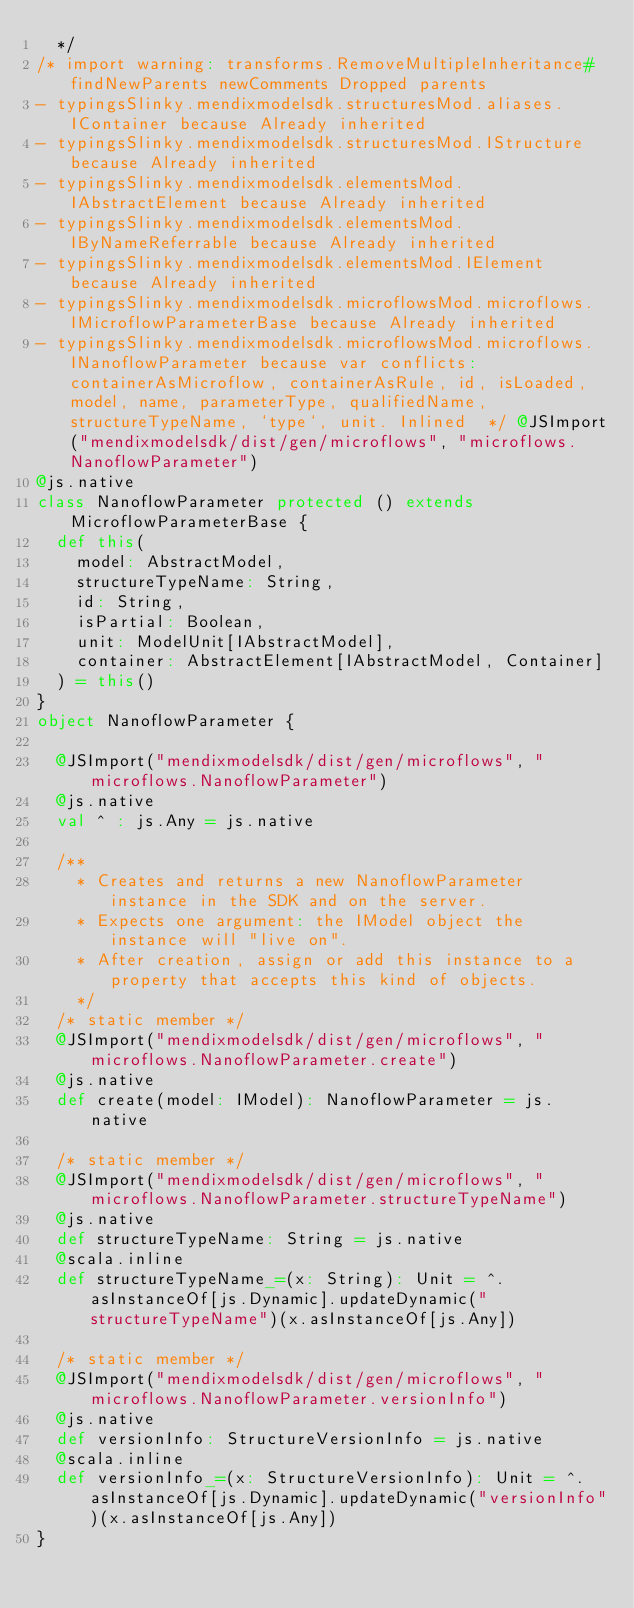<code> <loc_0><loc_0><loc_500><loc_500><_Scala_>  */
/* import warning: transforms.RemoveMultipleInheritance#findNewParents newComments Dropped parents 
- typingsSlinky.mendixmodelsdk.structuresMod.aliases.IContainer because Already inherited
- typingsSlinky.mendixmodelsdk.structuresMod.IStructure because Already inherited
- typingsSlinky.mendixmodelsdk.elementsMod.IAbstractElement because Already inherited
- typingsSlinky.mendixmodelsdk.elementsMod.IByNameReferrable because Already inherited
- typingsSlinky.mendixmodelsdk.elementsMod.IElement because Already inherited
- typingsSlinky.mendixmodelsdk.microflowsMod.microflows.IMicroflowParameterBase because Already inherited
- typingsSlinky.mendixmodelsdk.microflowsMod.microflows.INanoflowParameter because var conflicts: containerAsMicroflow, containerAsRule, id, isLoaded, model, name, parameterType, qualifiedName, structureTypeName, `type`, unit. Inlined  */ @JSImport("mendixmodelsdk/dist/gen/microflows", "microflows.NanoflowParameter")
@js.native
class NanoflowParameter protected () extends MicroflowParameterBase {
  def this(
    model: AbstractModel,
    structureTypeName: String,
    id: String,
    isPartial: Boolean,
    unit: ModelUnit[IAbstractModel],
    container: AbstractElement[IAbstractModel, Container]
  ) = this()
}
object NanoflowParameter {
  
  @JSImport("mendixmodelsdk/dist/gen/microflows", "microflows.NanoflowParameter")
  @js.native
  val ^ : js.Any = js.native
  
  /**
    * Creates and returns a new NanoflowParameter instance in the SDK and on the server.
    * Expects one argument: the IModel object the instance will "live on".
    * After creation, assign or add this instance to a property that accepts this kind of objects.
    */
  /* static member */
  @JSImport("mendixmodelsdk/dist/gen/microflows", "microflows.NanoflowParameter.create")
  @js.native
  def create(model: IModel): NanoflowParameter = js.native
  
  /* static member */
  @JSImport("mendixmodelsdk/dist/gen/microflows", "microflows.NanoflowParameter.structureTypeName")
  @js.native
  def structureTypeName: String = js.native
  @scala.inline
  def structureTypeName_=(x: String): Unit = ^.asInstanceOf[js.Dynamic].updateDynamic("structureTypeName")(x.asInstanceOf[js.Any])
  
  /* static member */
  @JSImport("mendixmodelsdk/dist/gen/microflows", "microflows.NanoflowParameter.versionInfo")
  @js.native
  def versionInfo: StructureVersionInfo = js.native
  @scala.inline
  def versionInfo_=(x: StructureVersionInfo): Unit = ^.asInstanceOf[js.Dynamic].updateDynamic("versionInfo")(x.asInstanceOf[js.Any])
}
</code> 